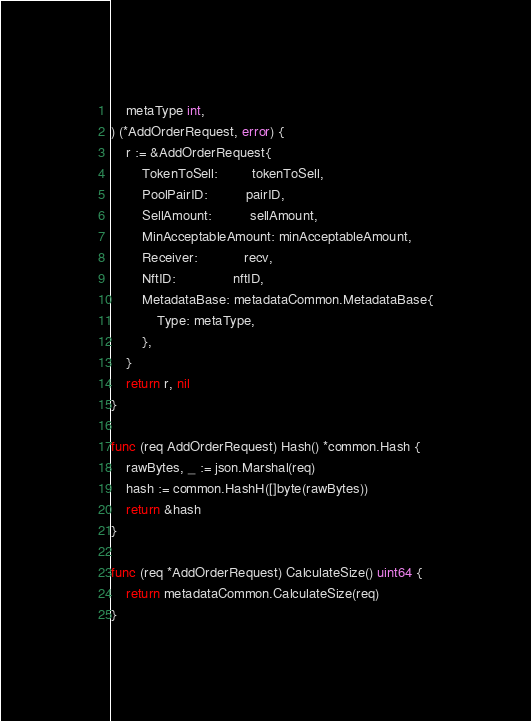Convert code to text. <code><loc_0><loc_0><loc_500><loc_500><_Go_>	metaType int,
) (*AddOrderRequest, error) {
	r := &AddOrderRequest{
		TokenToSell:         tokenToSell,
		PoolPairID:          pairID,
		SellAmount:          sellAmount,
		MinAcceptableAmount: minAcceptableAmount,
		Receiver:            recv,
		NftID:               nftID,
		MetadataBase: metadataCommon.MetadataBase{
			Type: metaType,
		},
	}
	return r, nil
}

func (req AddOrderRequest) Hash() *common.Hash {
	rawBytes, _ := json.Marshal(req)
	hash := common.HashH([]byte(rawBytes))
	return &hash
}

func (req *AddOrderRequest) CalculateSize() uint64 {
	return metadataCommon.CalculateSize(req)
}
</code> 